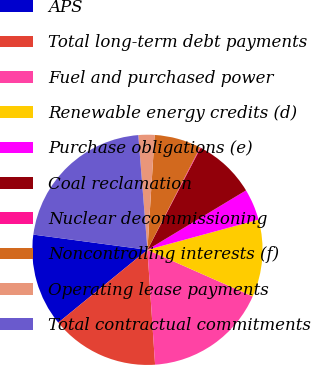Convert chart. <chart><loc_0><loc_0><loc_500><loc_500><pie_chart><fcel>APS<fcel>Total long-term debt payments<fcel>Fuel and purchased power<fcel>Renewable energy credits (d)<fcel>Purchase obligations (e)<fcel>Coal reclamation<fcel>Nuclear decommissioning<fcel>Noncontrolling interests (f)<fcel>Operating lease payments<fcel>Total contractual commitments<nl><fcel>13.01%<fcel>15.16%<fcel>17.31%<fcel>10.86%<fcel>4.41%<fcel>8.71%<fcel>0.1%<fcel>6.56%<fcel>2.26%<fcel>21.62%<nl></chart> 